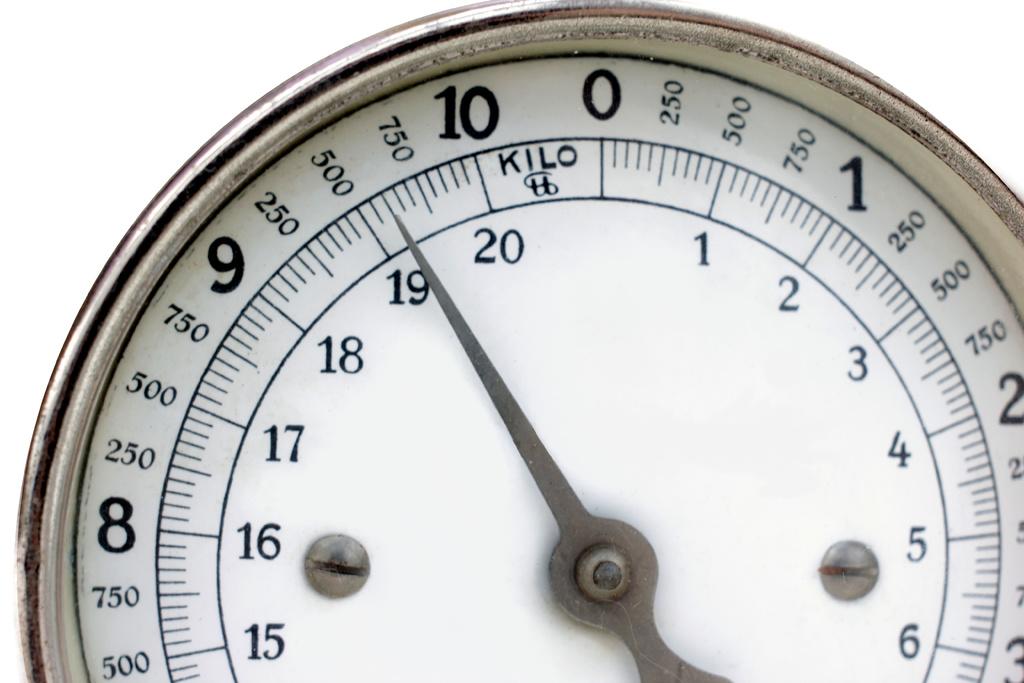How much does this scale read?
Ensure brevity in your answer.  600 kilo. What number is at the top of the scale?
Give a very brief answer. 0. 